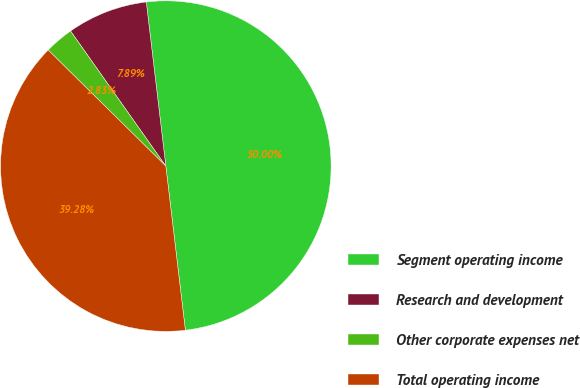Convert chart. <chart><loc_0><loc_0><loc_500><loc_500><pie_chart><fcel>Segment operating income<fcel>Research and development<fcel>Other corporate expenses net<fcel>Total operating income<nl><fcel>50.0%<fcel>7.89%<fcel>2.83%<fcel>39.28%<nl></chart> 